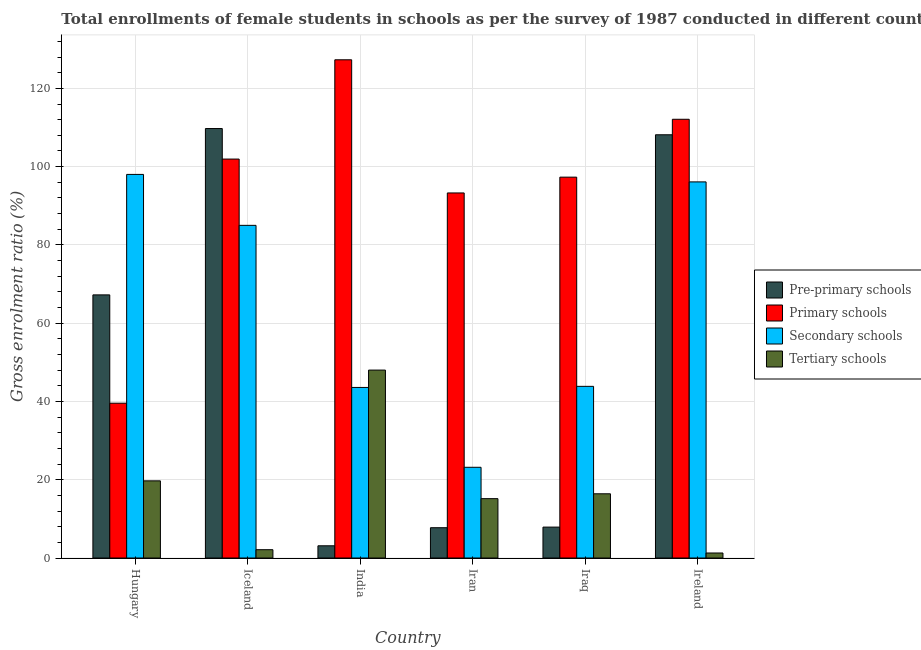How many different coloured bars are there?
Your answer should be very brief. 4. Are the number of bars per tick equal to the number of legend labels?
Ensure brevity in your answer.  Yes. Are the number of bars on each tick of the X-axis equal?
Offer a very short reply. Yes. How many bars are there on the 3rd tick from the right?
Provide a succinct answer. 4. What is the label of the 2nd group of bars from the left?
Make the answer very short. Iceland. In how many cases, is the number of bars for a given country not equal to the number of legend labels?
Keep it short and to the point. 0. What is the gross enrolment ratio(female) in tertiary schools in Ireland?
Offer a terse response. 1.28. Across all countries, what is the maximum gross enrolment ratio(female) in pre-primary schools?
Your response must be concise. 109.74. Across all countries, what is the minimum gross enrolment ratio(female) in pre-primary schools?
Make the answer very short. 3.12. In which country was the gross enrolment ratio(female) in tertiary schools maximum?
Make the answer very short. India. In which country was the gross enrolment ratio(female) in secondary schools minimum?
Provide a succinct answer. Iran. What is the total gross enrolment ratio(female) in tertiary schools in the graph?
Keep it short and to the point. 102.71. What is the difference between the gross enrolment ratio(female) in tertiary schools in Hungary and that in Iran?
Make the answer very short. 4.55. What is the difference between the gross enrolment ratio(female) in primary schools in Hungary and the gross enrolment ratio(female) in pre-primary schools in Iceland?
Make the answer very short. -70.18. What is the average gross enrolment ratio(female) in secondary schools per country?
Make the answer very short. 64.96. What is the difference between the gross enrolment ratio(female) in pre-primary schools and gross enrolment ratio(female) in tertiary schools in Iraq?
Make the answer very short. -8.51. What is the ratio of the gross enrolment ratio(female) in tertiary schools in Iran to that in Ireland?
Give a very brief answer. 11.83. Is the gross enrolment ratio(female) in pre-primary schools in India less than that in Ireland?
Keep it short and to the point. Yes. Is the difference between the gross enrolment ratio(female) in secondary schools in Iceland and Ireland greater than the difference between the gross enrolment ratio(female) in tertiary schools in Iceland and Ireland?
Your answer should be very brief. No. What is the difference between the highest and the second highest gross enrolment ratio(female) in pre-primary schools?
Offer a terse response. 1.59. What is the difference between the highest and the lowest gross enrolment ratio(female) in secondary schools?
Your answer should be very brief. 74.83. Is the sum of the gross enrolment ratio(female) in primary schools in India and Iraq greater than the maximum gross enrolment ratio(female) in pre-primary schools across all countries?
Your answer should be compact. Yes. What does the 2nd bar from the left in Ireland represents?
Your answer should be compact. Primary schools. What does the 4th bar from the right in Iraq represents?
Your response must be concise. Pre-primary schools. How many bars are there?
Your answer should be compact. 24. How many countries are there in the graph?
Your answer should be compact. 6. What is the difference between two consecutive major ticks on the Y-axis?
Offer a very short reply. 20. Are the values on the major ticks of Y-axis written in scientific E-notation?
Offer a terse response. No. How many legend labels are there?
Offer a terse response. 4. How are the legend labels stacked?
Provide a short and direct response. Vertical. What is the title of the graph?
Keep it short and to the point. Total enrollments of female students in schools as per the survey of 1987 conducted in different countries. Does "Greece" appear as one of the legend labels in the graph?
Ensure brevity in your answer.  No. What is the Gross enrolment ratio (%) in Pre-primary schools in Hungary?
Your answer should be compact. 67.23. What is the Gross enrolment ratio (%) of Primary schools in Hungary?
Your answer should be compact. 39.56. What is the Gross enrolment ratio (%) in Secondary schools in Hungary?
Your answer should be compact. 98.01. What is the Gross enrolment ratio (%) of Tertiary schools in Hungary?
Provide a short and direct response. 19.71. What is the Gross enrolment ratio (%) of Pre-primary schools in Iceland?
Offer a terse response. 109.74. What is the Gross enrolment ratio (%) in Primary schools in Iceland?
Ensure brevity in your answer.  101.94. What is the Gross enrolment ratio (%) in Secondary schools in Iceland?
Provide a short and direct response. 85. What is the Gross enrolment ratio (%) of Tertiary schools in Iceland?
Offer a very short reply. 2.12. What is the Gross enrolment ratio (%) in Pre-primary schools in India?
Ensure brevity in your answer.  3.12. What is the Gross enrolment ratio (%) of Primary schools in India?
Keep it short and to the point. 127.31. What is the Gross enrolment ratio (%) in Secondary schools in India?
Your response must be concise. 43.58. What is the Gross enrolment ratio (%) in Tertiary schools in India?
Offer a terse response. 48.02. What is the Gross enrolment ratio (%) of Pre-primary schools in Iran?
Give a very brief answer. 7.74. What is the Gross enrolment ratio (%) in Primary schools in Iran?
Provide a short and direct response. 93.28. What is the Gross enrolment ratio (%) of Secondary schools in Iran?
Your answer should be very brief. 23.18. What is the Gross enrolment ratio (%) of Tertiary schools in Iran?
Your response must be concise. 15.17. What is the Gross enrolment ratio (%) of Pre-primary schools in Iraq?
Your answer should be compact. 7.9. What is the Gross enrolment ratio (%) of Primary schools in Iraq?
Provide a succinct answer. 97.32. What is the Gross enrolment ratio (%) in Secondary schools in Iraq?
Offer a very short reply. 43.86. What is the Gross enrolment ratio (%) of Tertiary schools in Iraq?
Your response must be concise. 16.41. What is the Gross enrolment ratio (%) in Pre-primary schools in Ireland?
Provide a succinct answer. 108.15. What is the Gross enrolment ratio (%) of Primary schools in Ireland?
Your answer should be very brief. 112.1. What is the Gross enrolment ratio (%) of Secondary schools in Ireland?
Offer a terse response. 96.1. What is the Gross enrolment ratio (%) of Tertiary schools in Ireland?
Offer a very short reply. 1.28. Across all countries, what is the maximum Gross enrolment ratio (%) in Pre-primary schools?
Keep it short and to the point. 109.74. Across all countries, what is the maximum Gross enrolment ratio (%) of Primary schools?
Your response must be concise. 127.31. Across all countries, what is the maximum Gross enrolment ratio (%) in Secondary schools?
Your response must be concise. 98.01. Across all countries, what is the maximum Gross enrolment ratio (%) in Tertiary schools?
Make the answer very short. 48.02. Across all countries, what is the minimum Gross enrolment ratio (%) in Pre-primary schools?
Provide a succinct answer. 3.12. Across all countries, what is the minimum Gross enrolment ratio (%) of Primary schools?
Provide a short and direct response. 39.56. Across all countries, what is the minimum Gross enrolment ratio (%) of Secondary schools?
Your answer should be compact. 23.18. Across all countries, what is the minimum Gross enrolment ratio (%) of Tertiary schools?
Keep it short and to the point. 1.28. What is the total Gross enrolment ratio (%) of Pre-primary schools in the graph?
Your answer should be compact. 303.88. What is the total Gross enrolment ratio (%) in Primary schools in the graph?
Provide a succinct answer. 571.5. What is the total Gross enrolment ratio (%) of Secondary schools in the graph?
Your answer should be very brief. 389.74. What is the total Gross enrolment ratio (%) of Tertiary schools in the graph?
Your answer should be compact. 102.71. What is the difference between the Gross enrolment ratio (%) in Pre-primary schools in Hungary and that in Iceland?
Make the answer very short. -42.5. What is the difference between the Gross enrolment ratio (%) in Primary schools in Hungary and that in Iceland?
Your answer should be very brief. -62.38. What is the difference between the Gross enrolment ratio (%) in Secondary schools in Hungary and that in Iceland?
Give a very brief answer. 13.02. What is the difference between the Gross enrolment ratio (%) in Tertiary schools in Hungary and that in Iceland?
Your response must be concise. 17.59. What is the difference between the Gross enrolment ratio (%) of Pre-primary schools in Hungary and that in India?
Your answer should be very brief. 64.11. What is the difference between the Gross enrolment ratio (%) of Primary schools in Hungary and that in India?
Your answer should be compact. -87.75. What is the difference between the Gross enrolment ratio (%) in Secondary schools in Hungary and that in India?
Provide a short and direct response. 54.43. What is the difference between the Gross enrolment ratio (%) of Tertiary schools in Hungary and that in India?
Provide a short and direct response. -28.3. What is the difference between the Gross enrolment ratio (%) of Pre-primary schools in Hungary and that in Iran?
Your answer should be very brief. 59.49. What is the difference between the Gross enrolment ratio (%) in Primary schools in Hungary and that in Iran?
Give a very brief answer. -53.72. What is the difference between the Gross enrolment ratio (%) in Secondary schools in Hungary and that in Iran?
Ensure brevity in your answer.  74.83. What is the difference between the Gross enrolment ratio (%) of Tertiary schools in Hungary and that in Iran?
Keep it short and to the point. 4.55. What is the difference between the Gross enrolment ratio (%) in Pre-primary schools in Hungary and that in Iraq?
Provide a succinct answer. 59.34. What is the difference between the Gross enrolment ratio (%) of Primary schools in Hungary and that in Iraq?
Give a very brief answer. -57.76. What is the difference between the Gross enrolment ratio (%) of Secondary schools in Hungary and that in Iraq?
Give a very brief answer. 54.15. What is the difference between the Gross enrolment ratio (%) of Tertiary schools in Hungary and that in Iraq?
Provide a short and direct response. 3.31. What is the difference between the Gross enrolment ratio (%) in Pre-primary schools in Hungary and that in Ireland?
Your response must be concise. -40.91. What is the difference between the Gross enrolment ratio (%) in Primary schools in Hungary and that in Ireland?
Offer a very short reply. -72.55. What is the difference between the Gross enrolment ratio (%) of Secondary schools in Hungary and that in Ireland?
Make the answer very short. 1.91. What is the difference between the Gross enrolment ratio (%) of Tertiary schools in Hungary and that in Ireland?
Keep it short and to the point. 18.43. What is the difference between the Gross enrolment ratio (%) of Pre-primary schools in Iceland and that in India?
Offer a very short reply. 106.61. What is the difference between the Gross enrolment ratio (%) of Primary schools in Iceland and that in India?
Keep it short and to the point. -25.37. What is the difference between the Gross enrolment ratio (%) in Secondary schools in Iceland and that in India?
Your answer should be very brief. 41.42. What is the difference between the Gross enrolment ratio (%) in Tertiary schools in Iceland and that in India?
Your response must be concise. -45.9. What is the difference between the Gross enrolment ratio (%) of Pre-primary schools in Iceland and that in Iran?
Ensure brevity in your answer.  102. What is the difference between the Gross enrolment ratio (%) in Primary schools in Iceland and that in Iran?
Your answer should be compact. 8.66. What is the difference between the Gross enrolment ratio (%) of Secondary schools in Iceland and that in Iran?
Provide a succinct answer. 61.82. What is the difference between the Gross enrolment ratio (%) of Tertiary schools in Iceland and that in Iran?
Give a very brief answer. -13.04. What is the difference between the Gross enrolment ratio (%) of Pre-primary schools in Iceland and that in Iraq?
Your answer should be compact. 101.84. What is the difference between the Gross enrolment ratio (%) in Primary schools in Iceland and that in Iraq?
Your answer should be very brief. 4.62. What is the difference between the Gross enrolment ratio (%) in Secondary schools in Iceland and that in Iraq?
Keep it short and to the point. 41.14. What is the difference between the Gross enrolment ratio (%) of Tertiary schools in Iceland and that in Iraq?
Make the answer very short. -14.28. What is the difference between the Gross enrolment ratio (%) of Pre-primary schools in Iceland and that in Ireland?
Give a very brief answer. 1.59. What is the difference between the Gross enrolment ratio (%) in Primary schools in Iceland and that in Ireland?
Make the answer very short. -10.17. What is the difference between the Gross enrolment ratio (%) of Secondary schools in Iceland and that in Ireland?
Give a very brief answer. -11.1. What is the difference between the Gross enrolment ratio (%) of Tertiary schools in Iceland and that in Ireland?
Your answer should be very brief. 0.84. What is the difference between the Gross enrolment ratio (%) in Pre-primary schools in India and that in Iran?
Your answer should be very brief. -4.62. What is the difference between the Gross enrolment ratio (%) of Primary schools in India and that in Iran?
Give a very brief answer. 34.03. What is the difference between the Gross enrolment ratio (%) of Secondary schools in India and that in Iran?
Give a very brief answer. 20.4. What is the difference between the Gross enrolment ratio (%) in Tertiary schools in India and that in Iran?
Ensure brevity in your answer.  32.85. What is the difference between the Gross enrolment ratio (%) in Pre-primary schools in India and that in Iraq?
Your answer should be very brief. -4.78. What is the difference between the Gross enrolment ratio (%) of Primary schools in India and that in Iraq?
Your answer should be very brief. 29.99. What is the difference between the Gross enrolment ratio (%) in Secondary schools in India and that in Iraq?
Your answer should be compact. -0.28. What is the difference between the Gross enrolment ratio (%) of Tertiary schools in India and that in Iraq?
Make the answer very short. 31.61. What is the difference between the Gross enrolment ratio (%) of Pre-primary schools in India and that in Ireland?
Ensure brevity in your answer.  -105.02. What is the difference between the Gross enrolment ratio (%) in Primary schools in India and that in Ireland?
Provide a short and direct response. 15.2. What is the difference between the Gross enrolment ratio (%) of Secondary schools in India and that in Ireland?
Provide a short and direct response. -52.52. What is the difference between the Gross enrolment ratio (%) in Tertiary schools in India and that in Ireland?
Make the answer very short. 46.74. What is the difference between the Gross enrolment ratio (%) in Pre-primary schools in Iran and that in Iraq?
Offer a very short reply. -0.16. What is the difference between the Gross enrolment ratio (%) in Primary schools in Iran and that in Iraq?
Your answer should be very brief. -4.04. What is the difference between the Gross enrolment ratio (%) in Secondary schools in Iran and that in Iraq?
Make the answer very short. -20.68. What is the difference between the Gross enrolment ratio (%) in Tertiary schools in Iran and that in Iraq?
Provide a short and direct response. -1.24. What is the difference between the Gross enrolment ratio (%) in Pre-primary schools in Iran and that in Ireland?
Provide a succinct answer. -100.41. What is the difference between the Gross enrolment ratio (%) in Primary schools in Iran and that in Ireland?
Offer a terse response. -18.82. What is the difference between the Gross enrolment ratio (%) of Secondary schools in Iran and that in Ireland?
Offer a terse response. -72.92. What is the difference between the Gross enrolment ratio (%) in Tertiary schools in Iran and that in Ireland?
Offer a terse response. 13.88. What is the difference between the Gross enrolment ratio (%) of Pre-primary schools in Iraq and that in Ireland?
Provide a succinct answer. -100.25. What is the difference between the Gross enrolment ratio (%) in Primary schools in Iraq and that in Ireland?
Your answer should be compact. -14.79. What is the difference between the Gross enrolment ratio (%) in Secondary schools in Iraq and that in Ireland?
Make the answer very short. -52.24. What is the difference between the Gross enrolment ratio (%) in Tertiary schools in Iraq and that in Ireland?
Your answer should be very brief. 15.13. What is the difference between the Gross enrolment ratio (%) of Pre-primary schools in Hungary and the Gross enrolment ratio (%) of Primary schools in Iceland?
Provide a succinct answer. -34.7. What is the difference between the Gross enrolment ratio (%) of Pre-primary schools in Hungary and the Gross enrolment ratio (%) of Secondary schools in Iceland?
Your answer should be compact. -17.76. What is the difference between the Gross enrolment ratio (%) of Pre-primary schools in Hungary and the Gross enrolment ratio (%) of Tertiary schools in Iceland?
Provide a short and direct response. 65.11. What is the difference between the Gross enrolment ratio (%) in Primary schools in Hungary and the Gross enrolment ratio (%) in Secondary schools in Iceland?
Provide a succinct answer. -45.44. What is the difference between the Gross enrolment ratio (%) of Primary schools in Hungary and the Gross enrolment ratio (%) of Tertiary schools in Iceland?
Make the answer very short. 37.43. What is the difference between the Gross enrolment ratio (%) in Secondary schools in Hungary and the Gross enrolment ratio (%) in Tertiary schools in Iceland?
Provide a succinct answer. 95.89. What is the difference between the Gross enrolment ratio (%) in Pre-primary schools in Hungary and the Gross enrolment ratio (%) in Primary schools in India?
Keep it short and to the point. -60.07. What is the difference between the Gross enrolment ratio (%) in Pre-primary schools in Hungary and the Gross enrolment ratio (%) in Secondary schools in India?
Your answer should be very brief. 23.65. What is the difference between the Gross enrolment ratio (%) of Pre-primary schools in Hungary and the Gross enrolment ratio (%) of Tertiary schools in India?
Provide a succinct answer. 19.22. What is the difference between the Gross enrolment ratio (%) of Primary schools in Hungary and the Gross enrolment ratio (%) of Secondary schools in India?
Provide a succinct answer. -4.03. What is the difference between the Gross enrolment ratio (%) in Primary schools in Hungary and the Gross enrolment ratio (%) in Tertiary schools in India?
Your answer should be very brief. -8.46. What is the difference between the Gross enrolment ratio (%) of Secondary schools in Hungary and the Gross enrolment ratio (%) of Tertiary schools in India?
Offer a very short reply. 49.99. What is the difference between the Gross enrolment ratio (%) in Pre-primary schools in Hungary and the Gross enrolment ratio (%) in Primary schools in Iran?
Offer a terse response. -26.04. What is the difference between the Gross enrolment ratio (%) of Pre-primary schools in Hungary and the Gross enrolment ratio (%) of Secondary schools in Iran?
Give a very brief answer. 44.06. What is the difference between the Gross enrolment ratio (%) of Pre-primary schools in Hungary and the Gross enrolment ratio (%) of Tertiary schools in Iran?
Offer a terse response. 52.07. What is the difference between the Gross enrolment ratio (%) in Primary schools in Hungary and the Gross enrolment ratio (%) in Secondary schools in Iran?
Keep it short and to the point. 16.38. What is the difference between the Gross enrolment ratio (%) of Primary schools in Hungary and the Gross enrolment ratio (%) of Tertiary schools in Iran?
Offer a very short reply. 24.39. What is the difference between the Gross enrolment ratio (%) of Secondary schools in Hungary and the Gross enrolment ratio (%) of Tertiary schools in Iran?
Make the answer very short. 82.85. What is the difference between the Gross enrolment ratio (%) of Pre-primary schools in Hungary and the Gross enrolment ratio (%) of Primary schools in Iraq?
Provide a succinct answer. -30.08. What is the difference between the Gross enrolment ratio (%) of Pre-primary schools in Hungary and the Gross enrolment ratio (%) of Secondary schools in Iraq?
Provide a short and direct response. 23.37. What is the difference between the Gross enrolment ratio (%) of Pre-primary schools in Hungary and the Gross enrolment ratio (%) of Tertiary schools in Iraq?
Your answer should be compact. 50.83. What is the difference between the Gross enrolment ratio (%) of Primary schools in Hungary and the Gross enrolment ratio (%) of Secondary schools in Iraq?
Offer a very short reply. -4.3. What is the difference between the Gross enrolment ratio (%) of Primary schools in Hungary and the Gross enrolment ratio (%) of Tertiary schools in Iraq?
Your response must be concise. 23.15. What is the difference between the Gross enrolment ratio (%) in Secondary schools in Hungary and the Gross enrolment ratio (%) in Tertiary schools in Iraq?
Offer a terse response. 81.61. What is the difference between the Gross enrolment ratio (%) of Pre-primary schools in Hungary and the Gross enrolment ratio (%) of Primary schools in Ireland?
Offer a very short reply. -44.87. What is the difference between the Gross enrolment ratio (%) of Pre-primary schools in Hungary and the Gross enrolment ratio (%) of Secondary schools in Ireland?
Your response must be concise. -28.87. What is the difference between the Gross enrolment ratio (%) of Pre-primary schools in Hungary and the Gross enrolment ratio (%) of Tertiary schools in Ireland?
Offer a very short reply. 65.95. What is the difference between the Gross enrolment ratio (%) in Primary schools in Hungary and the Gross enrolment ratio (%) in Secondary schools in Ireland?
Offer a very short reply. -56.55. What is the difference between the Gross enrolment ratio (%) of Primary schools in Hungary and the Gross enrolment ratio (%) of Tertiary schools in Ireland?
Provide a succinct answer. 38.27. What is the difference between the Gross enrolment ratio (%) in Secondary schools in Hungary and the Gross enrolment ratio (%) in Tertiary schools in Ireland?
Provide a short and direct response. 96.73. What is the difference between the Gross enrolment ratio (%) of Pre-primary schools in Iceland and the Gross enrolment ratio (%) of Primary schools in India?
Your answer should be very brief. -17.57. What is the difference between the Gross enrolment ratio (%) of Pre-primary schools in Iceland and the Gross enrolment ratio (%) of Secondary schools in India?
Make the answer very short. 66.15. What is the difference between the Gross enrolment ratio (%) in Pre-primary schools in Iceland and the Gross enrolment ratio (%) in Tertiary schools in India?
Provide a succinct answer. 61.72. What is the difference between the Gross enrolment ratio (%) in Primary schools in Iceland and the Gross enrolment ratio (%) in Secondary schools in India?
Make the answer very short. 58.35. What is the difference between the Gross enrolment ratio (%) of Primary schools in Iceland and the Gross enrolment ratio (%) of Tertiary schools in India?
Your answer should be compact. 53.92. What is the difference between the Gross enrolment ratio (%) of Secondary schools in Iceland and the Gross enrolment ratio (%) of Tertiary schools in India?
Your answer should be very brief. 36.98. What is the difference between the Gross enrolment ratio (%) in Pre-primary schools in Iceland and the Gross enrolment ratio (%) in Primary schools in Iran?
Make the answer very short. 16.46. What is the difference between the Gross enrolment ratio (%) of Pre-primary schools in Iceland and the Gross enrolment ratio (%) of Secondary schools in Iran?
Your answer should be compact. 86.56. What is the difference between the Gross enrolment ratio (%) in Pre-primary schools in Iceland and the Gross enrolment ratio (%) in Tertiary schools in Iran?
Your response must be concise. 94.57. What is the difference between the Gross enrolment ratio (%) in Primary schools in Iceland and the Gross enrolment ratio (%) in Secondary schools in Iran?
Your response must be concise. 78.76. What is the difference between the Gross enrolment ratio (%) in Primary schools in Iceland and the Gross enrolment ratio (%) in Tertiary schools in Iran?
Your response must be concise. 86.77. What is the difference between the Gross enrolment ratio (%) in Secondary schools in Iceland and the Gross enrolment ratio (%) in Tertiary schools in Iran?
Make the answer very short. 69.83. What is the difference between the Gross enrolment ratio (%) in Pre-primary schools in Iceland and the Gross enrolment ratio (%) in Primary schools in Iraq?
Make the answer very short. 12.42. What is the difference between the Gross enrolment ratio (%) of Pre-primary schools in Iceland and the Gross enrolment ratio (%) of Secondary schools in Iraq?
Keep it short and to the point. 65.88. What is the difference between the Gross enrolment ratio (%) of Pre-primary schools in Iceland and the Gross enrolment ratio (%) of Tertiary schools in Iraq?
Make the answer very short. 93.33. What is the difference between the Gross enrolment ratio (%) of Primary schools in Iceland and the Gross enrolment ratio (%) of Secondary schools in Iraq?
Your answer should be very brief. 58.08. What is the difference between the Gross enrolment ratio (%) of Primary schools in Iceland and the Gross enrolment ratio (%) of Tertiary schools in Iraq?
Your answer should be very brief. 85.53. What is the difference between the Gross enrolment ratio (%) of Secondary schools in Iceland and the Gross enrolment ratio (%) of Tertiary schools in Iraq?
Your answer should be very brief. 68.59. What is the difference between the Gross enrolment ratio (%) of Pre-primary schools in Iceland and the Gross enrolment ratio (%) of Primary schools in Ireland?
Ensure brevity in your answer.  -2.37. What is the difference between the Gross enrolment ratio (%) of Pre-primary schools in Iceland and the Gross enrolment ratio (%) of Secondary schools in Ireland?
Your answer should be compact. 13.63. What is the difference between the Gross enrolment ratio (%) in Pre-primary schools in Iceland and the Gross enrolment ratio (%) in Tertiary schools in Ireland?
Provide a succinct answer. 108.45. What is the difference between the Gross enrolment ratio (%) of Primary schools in Iceland and the Gross enrolment ratio (%) of Secondary schools in Ireland?
Ensure brevity in your answer.  5.83. What is the difference between the Gross enrolment ratio (%) of Primary schools in Iceland and the Gross enrolment ratio (%) of Tertiary schools in Ireland?
Ensure brevity in your answer.  100.66. What is the difference between the Gross enrolment ratio (%) of Secondary schools in Iceland and the Gross enrolment ratio (%) of Tertiary schools in Ireland?
Offer a terse response. 83.72. What is the difference between the Gross enrolment ratio (%) in Pre-primary schools in India and the Gross enrolment ratio (%) in Primary schools in Iran?
Offer a terse response. -90.16. What is the difference between the Gross enrolment ratio (%) in Pre-primary schools in India and the Gross enrolment ratio (%) in Secondary schools in Iran?
Keep it short and to the point. -20.06. What is the difference between the Gross enrolment ratio (%) in Pre-primary schools in India and the Gross enrolment ratio (%) in Tertiary schools in Iran?
Offer a very short reply. -12.04. What is the difference between the Gross enrolment ratio (%) in Primary schools in India and the Gross enrolment ratio (%) in Secondary schools in Iran?
Offer a terse response. 104.13. What is the difference between the Gross enrolment ratio (%) of Primary schools in India and the Gross enrolment ratio (%) of Tertiary schools in Iran?
Your response must be concise. 112.14. What is the difference between the Gross enrolment ratio (%) of Secondary schools in India and the Gross enrolment ratio (%) of Tertiary schools in Iran?
Your answer should be compact. 28.42. What is the difference between the Gross enrolment ratio (%) in Pre-primary schools in India and the Gross enrolment ratio (%) in Primary schools in Iraq?
Provide a succinct answer. -94.2. What is the difference between the Gross enrolment ratio (%) of Pre-primary schools in India and the Gross enrolment ratio (%) of Secondary schools in Iraq?
Provide a succinct answer. -40.74. What is the difference between the Gross enrolment ratio (%) of Pre-primary schools in India and the Gross enrolment ratio (%) of Tertiary schools in Iraq?
Give a very brief answer. -13.29. What is the difference between the Gross enrolment ratio (%) of Primary schools in India and the Gross enrolment ratio (%) of Secondary schools in Iraq?
Offer a terse response. 83.45. What is the difference between the Gross enrolment ratio (%) of Primary schools in India and the Gross enrolment ratio (%) of Tertiary schools in Iraq?
Your response must be concise. 110.9. What is the difference between the Gross enrolment ratio (%) of Secondary schools in India and the Gross enrolment ratio (%) of Tertiary schools in Iraq?
Provide a succinct answer. 27.17. What is the difference between the Gross enrolment ratio (%) of Pre-primary schools in India and the Gross enrolment ratio (%) of Primary schools in Ireland?
Make the answer very short. -108.98. What is the difference between the Gross enrolment ratio (%) of Pre-primary schools in India and the Gross enrolment ratio (%) of Secondary schools in Ireland?
Offer a terse response. -92.98. What is the difference between the Gross enrolment ratio (%) in Pre-primary schools in India and the Gross enrolment ratio (%) in Tertiary schools in Ireland?
Your response must be concise. 1.84. What is the difference between the Gross enrolment ratio (%) in Primary schools in India and the Gross enrolment ratio (%) in Secondary schools in Ireland?
Make the answer very short. 31.2. What is the difference between the Gross enrolment ratio (%) of Primary schools in India and the Gross enrolment ratio (%) of Tertiary schools in Ireland?
Your answer should be very brief. 126.02. What is the difference between the Gross enrolment ratio (%) of Secondary schools in India and the Gross enrolment ratio (%) of Tertiary schools in Ireland?
Your response must be concise. 42.3. What is the difference between the Gross enrolment ratio (%) of Pre-primary schools in Iran and the Gross enrolment ratio (%) of Primary schools in Iraq?
Make the answer very short. -89.58. What is the difference between the Gross enrolment ratio (%) in Pre-primary schools in Iran and the Gross enrolment ratio (%) in Secondary schools in Iraq?
Offer a very short reply. -36.12. What is the difference between the Gross enrolment ratio (%) of Pre-primary schools in Iran and the Gross enrolment ratio (%) of Tertiary schools in Iraq?
Offer a terse response. -8.67. What is the difference between the Gross enrolment ratio (%) in Primary schools in Iran and the Gross enrolment ratio (%) in Secondary schools in Iraq?
Your response must be concise. 49.42. What is the difference between the Gross enrolment ratio (%) in Primary schools in Iran and the Gross enrolment ratio (%) in Tertiary schools in Iraq?
Keep it short and to the point. 76.87. What is the difference between the Gross enrolment ratio (%) in Secondary schools in Iran and the Gross enrolment ratio (%) in Tertiary schools in Iraq?
Ensure brevity in your answer.  6.77. What is the difference between the Gross enrolment ratio (%) in Pre-primary schools in Iran and the Gross enrolment ratio (%) in Primary schools in Ireland?
Give a very brief answer. -104.36. What is the difference between the Gross enrolment ratio (%) in Pre-primary schools in Iran and the Gross enrolment ratio (%) in Secondary schools in Ireland?
Provide a succinct answer. -88.36. What is the difference between the Gross enrolment ratio (%) in Pre-primary schools in Iran and the Gross enrolment ratio (%) in Tertiary schools in Ireland?
Make the answer very short. 6.46. What is the difference between the Gross enrolment ratio (%) of Primary schools in Iran and the Gross enrolment ratio (%) of Secondary schools in Ireland?
Ensure brevity in your answer.  -2.82. What is the difference between the Gross enrolment ratio (%) of Primary schools in Iran and the Gross enrolment ratio (%) of Tertiary schools in Ireland?
Offer a very short reply. 92. What is the difference between the Gross enrolment ratio (%) of Secondary schools in Iran and the Gross enrolment ratio (%) of Tertiary schools in Ireland?
Offer a very short reply. 21.9. What is the difference between the Gross enrolment ratio (%) of Pre-primary schools in Iraq and the Gross enrolment ratio (%) of Primary schools in Ireland?
Provide a short and direct response. -104.2. What is the difference between the Gross enrolment ratio (%) in Pre-primary schools in Iraq and the Gross enrolment ratio (%) in Secondary schools in Ireland?
Provide a succinct answer. -88.2. What is the difference between the Gross enrolment ratio (%) of Pre-primary schools in Iraq and the Gross enrolment ratio (%) of Tertiary schools in Ireland?
Your response must be concise. 6.62. What is the difference between the Gross enrolment ratio (%) in Primary schools in Iraq and the Gross enrolment ratio (%) in Secondary schools in Ireland?
Your answer should be very brief. 1.22. What is the difference between the Gross enrolment ratio (%) in Primary schools in Iraq and the Gross enrolment ratio (%) in Tertiary schools in Ireland?
Provide a short and direct response. 96.04. What is the difference between the Gross enrolment ratio (%) of Secondary schools in Iraq and the Gross enrolment ratio (%) of Tertiary schools in Ireland?
Offer a very short reply. 42.58. What is the average Gross enrolment ratio (%) in Pre-primary schools per country?
Give a very brief answer. 50.65. What is the average Gross enrolment ratio (%) in Primary schools per country?
Give a very brief answer. 95.25. What is the average Gross enrolment ratio (%) of Secondary schools per country?
Give a very brief answer. 64.96. What is the average Gross enrolment ratio (%) of Tertiary schools per country?
Keep it short and to the point. 17.12. What is the difference between the Gross enrolment ratio (%) of Pre-primary schools and Gross enrolment ratio (%) of Primary schools in Hungary?
Offer a terse response. 27.68. What is the difference between the Gross enrolment ratio (%) in Pre-primary schools and Gross enrolment ratio (%) in Secondary schools in Hungary?
Offer a very short reply. -30.78. What is the difference between the Gross enrolment ratio (%) of Pre-primary schools and Gross enrolment ratio (%) of Tertiary schools in Hungary?
Your answer should be very brief. 47.52. What is the difference between the Gross enrolment ratio (%) in Primary schools and Gross enrolment ratio (%) in Secondary schools in Hungary?
Your answer should be very brief. -58.46. What is the difference between the Gross enrolment ratio (%) of Primary schools and Gross enrolment ratio (%) of Tertiary schools in Hungary?
Offer a terse response. 19.84. What is the difference between the Gross enrolment ratio (%) of Secondary schools and Gross enrolment ratio (%) of Tertiary schools in Hungary?
Give a very brief answer. 78.3. What is the difference between the Gross enrolment ratio (%) of Pre-primary schools and Gross enrolment ratio (%) of Primary schools in Iceland?
Your response must be concise. 7.8. What is the difference between the Gross enrolment ratio (%) of Pre-primary schools and Gross enrolment ratio (%) of Secondary schools in Iceland?
Your answer should be compact. 24.74. What is the difference between the Gross enrolment ratio (%) of Pre-primary schools and Gross enrolment ratio (%) of Tertiary schools in Iceland?
Your answer should be compact. 107.61. What is the difference between the Gross enrolment ratio (%) in Primary schools and Gross enrolment ratio (%) in Secondary schools in Iceland?
Provide a short and direct response. 16.94. What is the difference between the Gross enrolment ratio (%) in Primary schools and Gross enrolment ratio (%) in Tertiary schools in Iceland?
Ensure brevity in your answer.  99.81. What is the difference between the Gross enrolment ratio (%) of Secondary schools and Gross enrolment ratio (%) of Tertiary schools in Iceland?
Provide a short and direct response. 82.88. What is the difference between the Gross enrolment ratio (%) of Pre-primary schools and Gross enrolment ratio (%) of Primary schools in India?
Keep it short and to the point. -124.18. What is the difference between the Gross enrolment ratio (%) of Pre-primary schools and Gross enrolment ratio (%) of Secondary schools in India?
Provide a succinct answer. -40.46. What is the difference between the Gross enrolment ratio (%) in Pre-primary schools and Gross enrolment ratio (%) in Tertiary schools in India?
Provide a short and direct response. -44.9. What is the difference between the Gross enrolment ratio (%) of Primary schools and Gross enrolment ratio (%) of Secondary schools in India?
Your answer should be very brief. 83.72. What is the difference between the Gross enrolment ratio (%) of Primary schools and Gross enrolment ratio (%) of Tertiary schools in India?
Your answer should be compact. 79.29. What is the difference between the Gross enrolment ratio (%) in Secondary schools and Gross enrolment ratio (%) in Tertiary schools in India?
Ensure brevity in your answer.  -4.44. What is the difference between the Gross enrolment ratio (%) in Pre-primary schools and Gross enrolment ratio (%) in Primary schools in Iran?
Offer a terse response. -85.54. What is the difference between the Gross enrolment ratio (%) of Pre-primary schools and Gross enrolment ratio (%) of Secondary schools in Iran?
Your answer should be compact. -15.44. What is the difference between the Gross enrolment ratio (%) of Pre-primary schools and Gross enrolment ratio (%) of Tertiary schools in Iran?
Your response must be concise. -7.43. What is the difference between the Gross enrolment ratio (%) of Primary schools and Gross enrolment ratio (%) of Secondary schools in Iran?
Keep it short and to the point. 70.1. What is the difference between the Gross enrolment ratio (%) in Primary schools and Gross enrolment ratio (%) in Tertiary schools in Iran?
Provide a short and direct response. 78.11. What is the difference between the Gross enrolment ratio (%) in Secondary schools and Gross enrolment ratio (%) in Tertiary schools in Iran?
Your answer should be very brief. 8.01. What is the difference between the Gross enrolment ratio (%) of Pre-primary schools and Gross enrolment ratio (%) of Primary schools in Iraq?
Offer a terse response. -89.42. What is the difference between the Gross enrolment ratio (%) in Pre-primary schools and Gross enrolment ratio (%) in Secondary schools in Iraq?
Your response must be concise. -35.96. What is the difference between the Gross enrolment ratio (%) of Pre-primary schools and Gross enrolment ratio (%) of Tertiary schools in Iraq?
Your response must be concise. -8.51. What is the difference between the Gross enrolment ratio (%) in Primary schools and Gross enrolment ratio (%) in Secondary schools in Iraq?
Keep it short and to the point. 53.46. What is the difference between the Gross enrolment ratio (%) of Primary schools and Gross enrolment ratio (%) of Tertiary schools in Iraq?
Your answer should be compact. 80.91. What is the difference between the Gross enrolment ratio (%) in Secondary schools and Gross enrolment ratio (%) in Tertiary schools in Iraq?
Your answer should be very brief. 27.45. What is the difference between the Gross enrolment ratio (%) of Pre-primary schools and Gross enrolment ratio (%) of Primary schools in Ireland?
Offer a very short reply. -3.96. What is the difference between the Gross enrolment ratio (%) in Pre-primary schools and Gross enrolment ratio (%) in Secondary schools in Ireland?
Your response must be concise. 12.04. What is the difference between the Gross enrolment ratio (%) in Pre-primary schools and Gross enrolment ratio (%) in Tertiary schools in Ireland?
Make the answer very short. 106.86. What is the difference between the Gross enrolment ratio (%) of Primary schools and Gross enrolment ratio (%) of Secondary schools in Ireland?
Offer a terse response. 16. What is the difference between the Gross enrolment ratio (%) in Primary schools and Gross enrolment ratio (%) in Tertiary schools in Ireland?
Ensure brevity in your answer.  110.82. What is the difference between the Gross enrolment ratio (%) in Secondary schools and Gross enrolment ratio (%) in Tertiary schools in Ireland?
Offer a very short reply. 94.82. What is the ratio of the Gross enrolment ratio (%) in Pre-primary schools in Hungary to that in Iceland?
Ensure brevity in your answer.  0.61. What is the ratio of the Gross enrolment ratio (%) of Primary schools in Hungary to that in Iceland?
Your answer should be compact. 0.39. What is the ratio of the Gross enrolment ratio (%) in Secondary schools in Hungary to that in Iceland?
Your response must be concise. 1.15. What is the ratio of the Gross enrolment ratio (%) of Tertiary schools in Hungary to that in Iceland?
Offer a terse response. 9.28. What is the ratio of the Gross enrolment ratio (%) of Pre-primary schools in Hungary to that in India?
Provide a succinct answer. 21.53. What is the ratio of the Gross enrolment ratio (%) in Primary schools in Hungary to that in India?
Give a very brief answer. 0.31. What is the ratio of the Gross enrolment ratio (%) of Secondary schools in Hungary to that in India?
Offer a terse response. 2.25. What is the ratio of the Gross enrolment ratio (%) of Tertiary schools in Hungary to that in India?
Your answer should be compact. 0.41. What is the ratio of the Gross enrolment ratio (%) in Pre-primary schools in Hungary to that in Iran?
Give a very brief answer. 8.69. What is the ratio of the Gross enrolment ratio (%) in Primary schools in Hungary to that in Iran?
Your response must be concise. 0.42. What is the ratio of the Gross enrolment ratio (%) of Secondary schools in Hungary to that in Iran?
Offer a very short reply. 4.23. What is the ratio of the Gross enrolment ratio (%) in Tertiary schools in Hungary to that in Iran?
Keep it short and to the point. 1.3. What is the ratio of the Gross enrolment ratio (%) of Pre-primary schools in Hungary to that in Iraq?
Offer a terse response. 8.51. What is the ratio of the Gross enrolment ratio (%) of Primary schools in Hungary to that in Iraq?
Keep it short and to the point. 0.41. What is the ratio of the Gross enrolment ratio (%) of Secondary schools in Hungary to that in Iraq?
Your answer should be compact. 2.23. What is the ratio of the Gross enrolment ratio (%) in Tertiary schools in Hungary to that in Iraq?
Provide a short and direct response. 1.2. What is the ratio of the Gross enrolment ratio (%) in Pre-primary schools in Hungary to that in Ireland?
Your response must be concise. 0.62. What is the ratio of the Gross enrolment ratio (%) in Primary schools in Hungary to that in Ireland?
Offer a very short reply. 0.35. What is the ratio of the Gross enrolment ratio (%) in Secondary schools in Hungary to that in Ireland?
Make the answer very short. 1.02. What is the ratio of the Gross enrolment ratio (%) in Tertiary schools in Hungary to that in Ireland?
Make the answer very short. 15.38. What is the ratio of the Gross enrolment ratio (%) of Pre-primary schools in Iceland to that in India?
Keep it short and to the point. 35.15. What is the ratio of the Gross enrolment ratio (%) of Primary schools in Iceland to that in India?
Your answer should be very brief. 0.8. What is the ratio of the Gross enrolment ratio (%) of Secondary schools in Iceland to that in India?
Your response must be concise. 1.95. What is the ratio of the Gross enrolment ratio (%) of Tertiary schools in Iceland to that in India?
Your response must be concise. 0.04. What is the ratio of the Gross enrolment ratio (%) in Pre-primary schools in Iceland to that in Iran?
Offer a terse response. 14.18. What is the ratio of the Gross enrolment ratio (%) of Primary schools in Iceland to that in Iran?
Your answer should be compact. 1.09. What is the ratio of the Gross enrolment ratio (%) of Secondary schools in Iceland to that in Iran?
Make the answer very short. 3.67. What is the ratio of the Gross enrolment ratio (%) in Tertiary schools in Iceland to that in Iran?
Your answer should be compact. 0.14. What is the ratio of the Gross enrolment ratio (%) of Pre-primary schools in Iceland to that in Iraq?
Make the answer very short. 13.89. What is the ratio of the Gross enrolment ratio (%) in Primary schools in Iceland to that in Iraq?
Ensure brevity in your answer.  1.05. What is the ratio of the Gross enrolment ratio (%) in Secondary schools in Iceland to that in Iraq?
Keep it short and to the point. 1.94. What is the ratio of the Gross enrolment ratio (%) of Tertiary schools in Iceland to that in Iraq?
Your answer should be very brief. 0.13. What is the ratio of the Gross enrolment ratio (%) of Pre-primary schools in Iceland to that in Ireland?
Your answer should be compact. 1.01. What is the ratio of the Gross enrolment ratio (%) of Primary schools in Iceland to that in Ireland?
Keep it short and to the point. 0.91. What is the ratio of the Gross enrolment ratio (%) of Secondary schools in Iceland to that in Ireland?
Keep it short and to the point. 0.88. What is the ratio of the Gross enrolment ratio (%) in Tertiary schools in Iceland to that in Ireland?
Provide a short and direct response. 1.66. What is the ratio of the Gross enrolment ratio (%) of Pre-primary schools in India to that in Iran?
Provide a short and direct response. 0.4. What is the ratio of the Gross enrolment ratio (%) of Primary schools in India to that in Iran?
Give a very brief answer. 1.36. What is the ratio of the Gross enrolment ratio (%) of Secondary schools in India to that in Iran?
Provide a short and direct response. 1.88. What is the ratio of the Gross enrolment ratio (%) of Tertiary schools in India to that in Iran?
Offer a terse response. 3.17. What is the ratio of the Gross enrolment ratio (%) of Pre-primary schools in India to that in Iraq?
Make the answer very short. 0.4. What is the ratio of the Gross enrolment ratio (%) of Primary schools in India to that in Iraq?
Provide a succinct answer. 1.31. What is the ratio of the Gross enrolment ratio (%) in Tertiary schools in India to that in Iraq?
Your response must be concise. 2.93. What is the ratio of the Gross enrolment ratio (%) of Pre-primary schools in India to that in Ireland?
Make the answer very short. 0.03. What is the ratio of the Gross enrolment ratio (%) in Primary schools in India to that in Ireland?
Ensure brevity in your answer.  1.14. What is the ratio of the Gross enrolment ratio (%) in Secondary schools in India to that in Ireland?
Your answer should be compact. 0.45. What is the ratio of the Gross enrolment ratio (%) of Tertiary schools in India to that in Ireland?
Keep it short and to the point. 37.46. What is the ratio of the Gross enrolment ratio (%) in Pre-primary schools in Iran to that in Iraq?
Your answer should be very brief. 0.98. What is the ratio of the Gross enrolment ratio (%) in Primary schools in Iran to that in Iraq?
Offer a very short reply. 0.96. What is the ratio of the Gross enrolment ratio (%) in Secondary schools in Iran to that in Iraq?
Offer a very short reply. 0.53. What is the ratio of the Gross enrolment ratio (%) in Tertiary schools in Iran to that in Iraq?
Provide a short and direct response. 0.92. What is the ratio of the Gross enrolment ratio (%) of Pre-primary schools in Iran to that in Ireland?
Ensure brevity in your answer.  0.07. What is the ratio of the Gross enrolment ratio (%) of Primary schools in Iran to that in Ireland?
Provide a succinct answer. 0.83. What is the ratio of the Gross enrolment ratio (%) in Secondary schools in Iran to that in Ireland?
Your answer should be compact. 0.24. What is the ratio of the Gross enrolment ratio (%) in Tertiary schools in Iran to that in Ireland?
Provide a short and direct response. 11.83. What is the ratio of the Gross enrolment ratio (%) in Pre-primary schools in Iraq to that in Ireland?
Give a very brief answer. 0.07. What is the ratio of the Gross enrolment ratio (%) of Primary schools in Iraq to that in Ireland?
Offer a very short reply. 0.87. What is the ratio of the Gross enrolment ratio (%) of Secondary schools in Iraq to that in Ireland?
Your answer should be very brief. 0.46. What is the ratio of the Gross enrolment ratio (%) in Tertiary schools in Iraq to that in Ireland?
Your response must be concise. 12.8. What is the difference between the highest and the second highest Gross enrolment ratio (%) of Pre-primary schools?
Your answer should be very brief. 1.59. What is the difference between the highest and the second highest Gross enrolment ratio (%) of Primary schools?
Provide a short and direct response. 15.2. What is the difference between the highest and the second highest Gross enrolment ratio (%) of Secondary schools?
Ensure brevity in your answer.  1.91. What is the difference between the highest and the second highest Gross enrolment ratio (%) of Tertiary schools?
Your answer should be very brief. 28.3. What is the difference between the highest and the lowest Gross enrolment ratio (%) in Pre-primary schools?
Your answer should be very brief. 106.61. What is the difference between the highest and the lowest Gross enrolment ratio (%) in Primary schools?
Make the answer very short. 87.75. What is the difference between the highest and the lowest Gross enrolment ratio (%) in Secondary schools?
Provide a succinct answer. 74.83. What is the difference between the highest and the lowest Gross enrolment ratio (%) in Tertiary schools?
Ensure brevity in your answer.  46.74. 